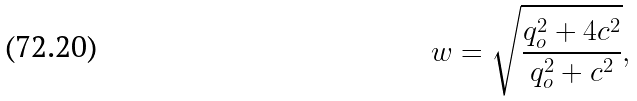<formula> <loc_0><loc_0><loc_500><loc_500>w = \sqrt { \frac { q _ { o } ^ { 2 } + 4 c ^ { 2 } } { q _ { o } ^ { 2 } + c ^ { 2 } } } ,</formula> 